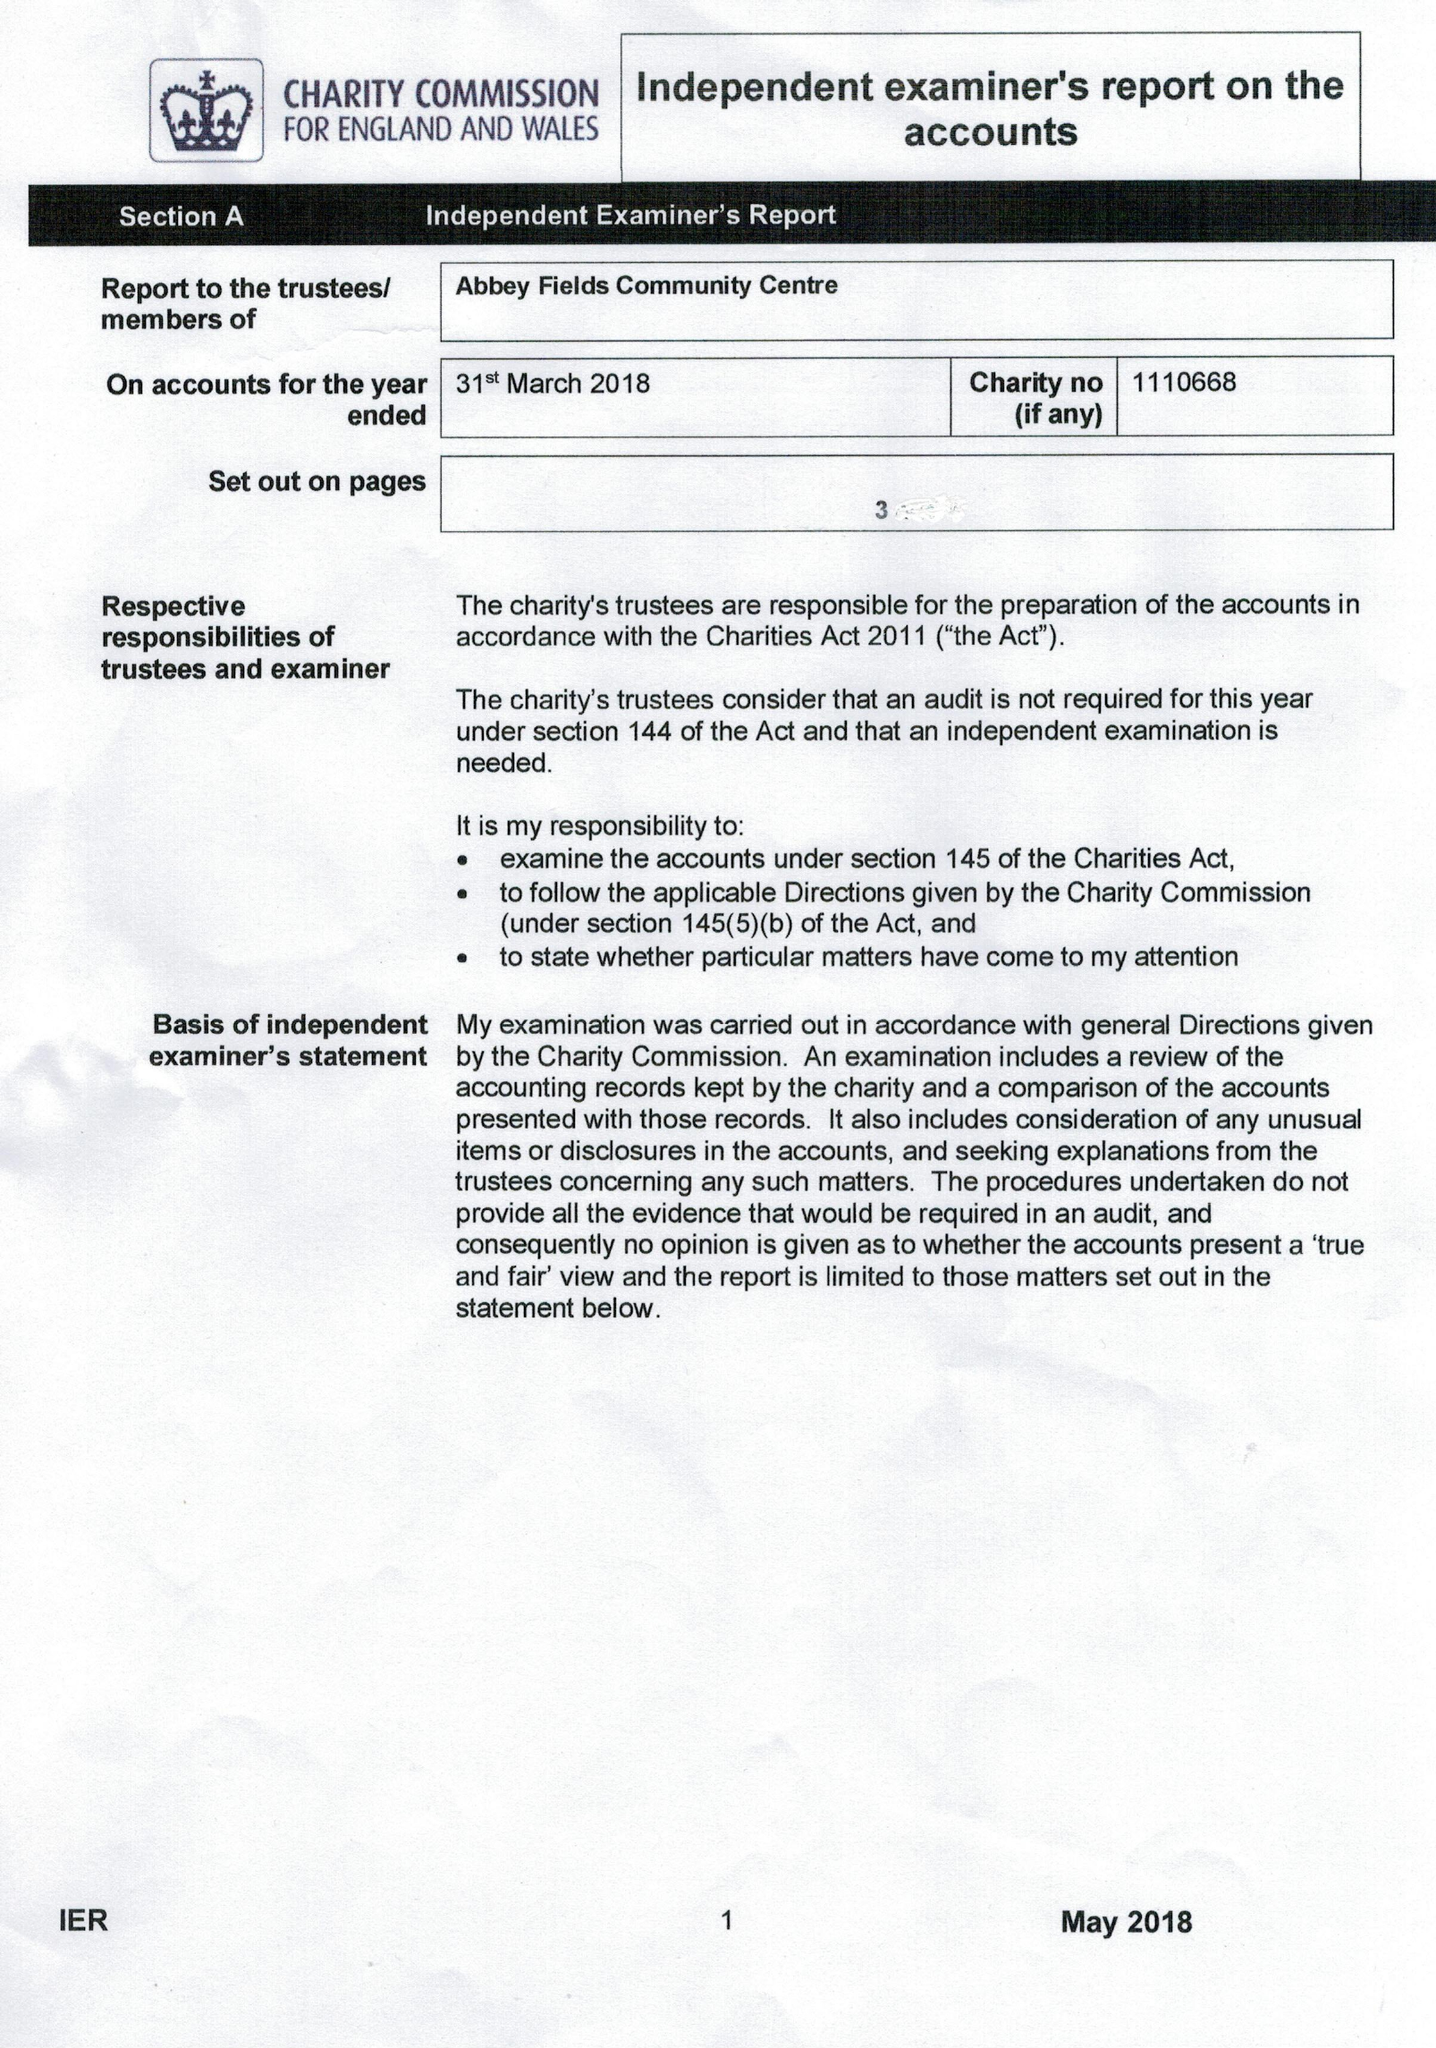What is the value for the charity_name?
Answer the question using a single word or phrase. Abbey Fields Community Centre 